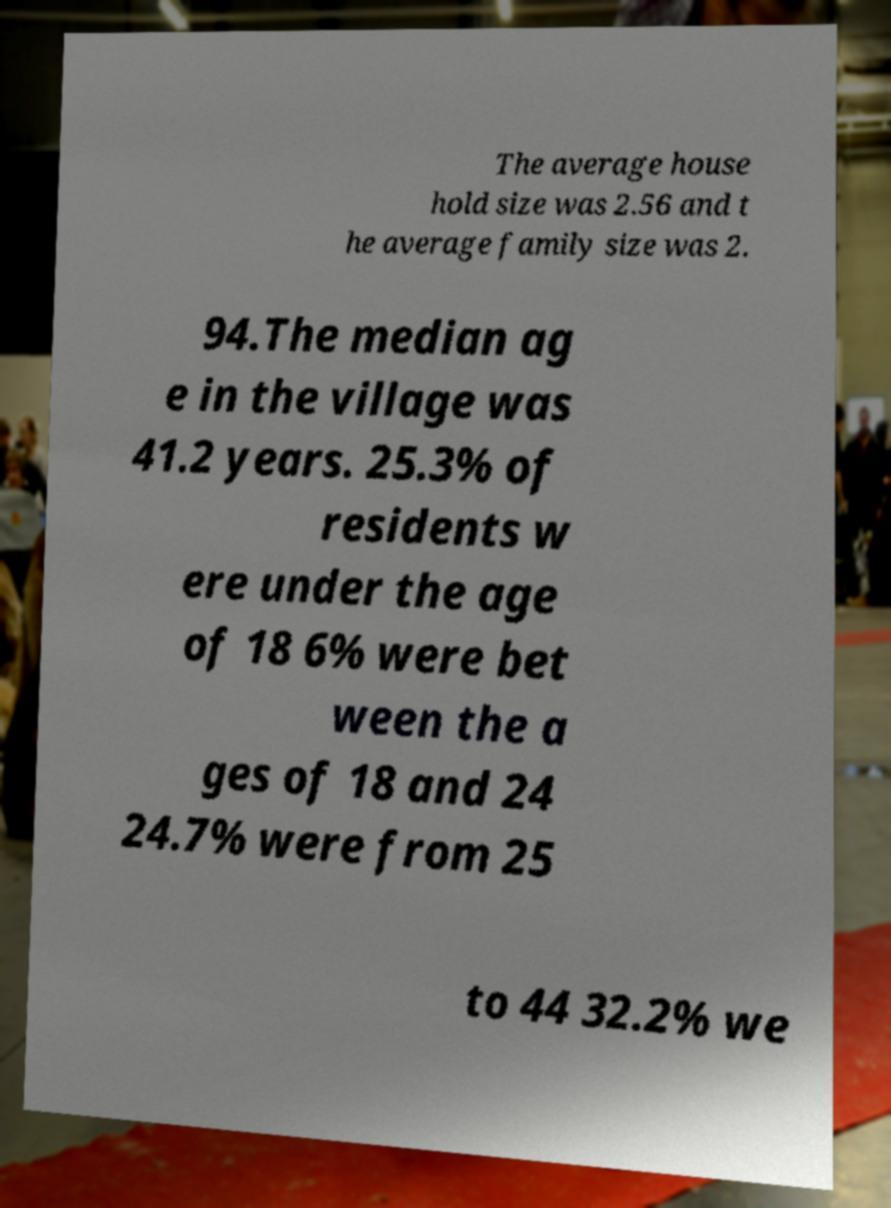Could you assist in decoding the text presented in this image and type it out clearly? The average house hold size was 2.56 and t he average family size was 2. 94.The median ag e in the village was 41.2 years. 25.3% of residents w ere under the age of 18 6% were bet ween the a ges of 18 and 24 24.7% were from 25 to 44 32.2% we 